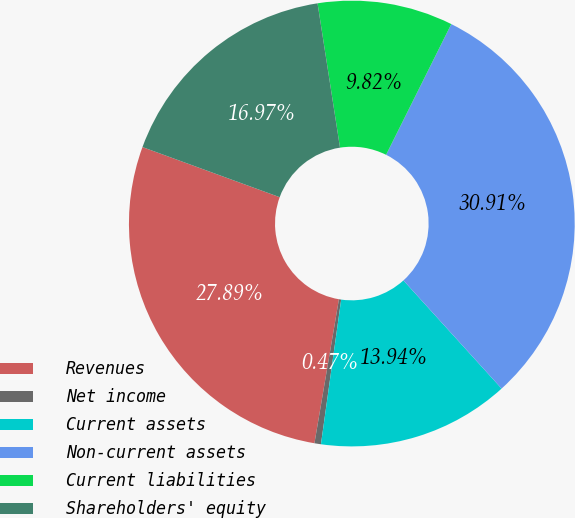<chart> <loc_0><loc_0><loc_500><loc_500><pie_chart><fcel>Revenues<fcel>Net income<fcel>Current assets<fcel>Non-current assets<fcel>Current liabilities<fcel>Shareholders' equity<nl><fcel>27.89%<fcel>0.47%<fcel>13.94%<fcel>30.91%<fcel>9.82%<fcel>16.97%<nl></chart> 